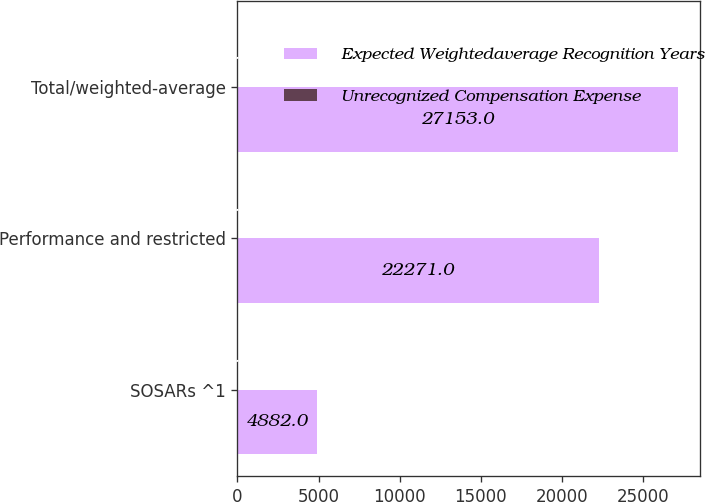Convert chart to OTSL. <chart><loc_0><loc_0><loc_500><loc_500><stacked_bar_chart><ecel><fcel>SOSARs ^1<fcel>Performance and restricted<fcel>Total/weighted-average<nl><fcel>Expected Weightedaverage Recognition Years<fcel>4882<fcel>22271<fcel>27153<nl><fcel>Unrecognized Compensation Expense<fcel>1.6<fcel>2.5<fcel>2.3<nl></chart> 